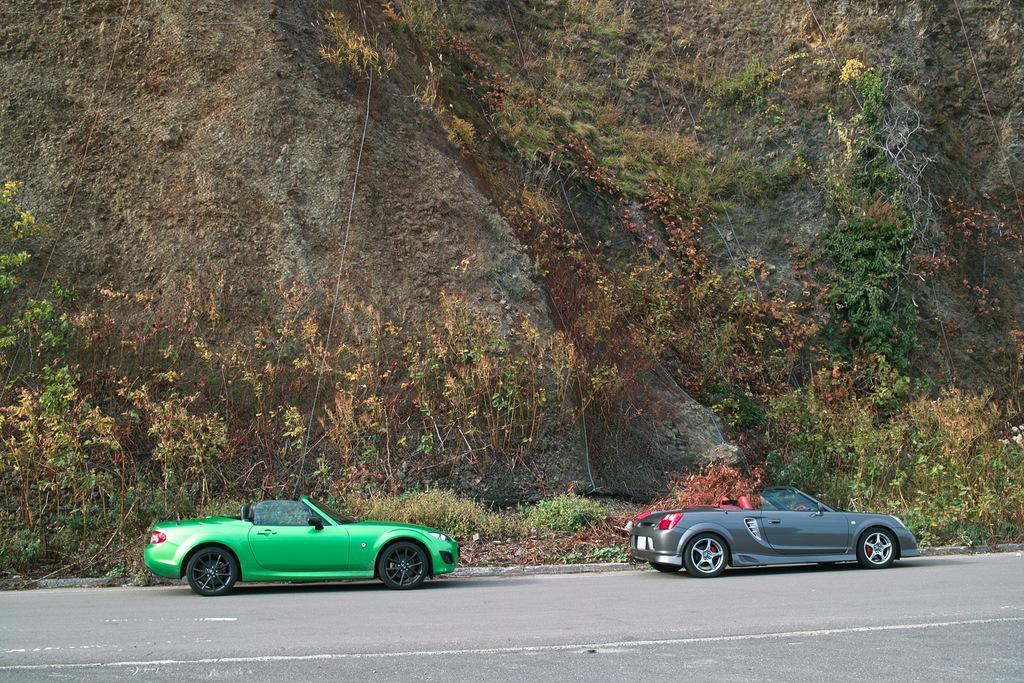Can you describe this image briefly? In this image we can see two cars parked on the road. In the background, we can see group of plants and mountain. 